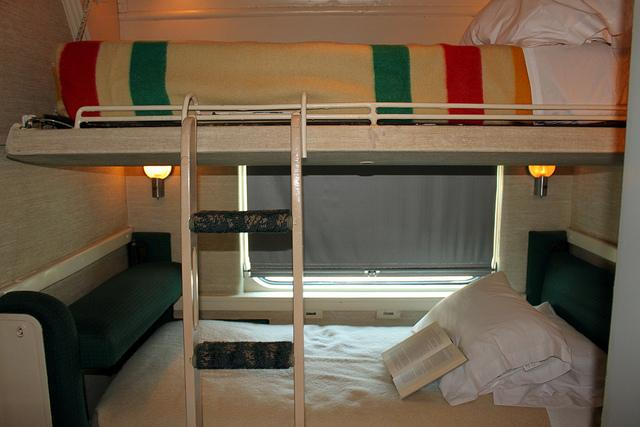Where might these sleeping quarters be located? Please explain your reasoning. train. The quarters are on a train. 